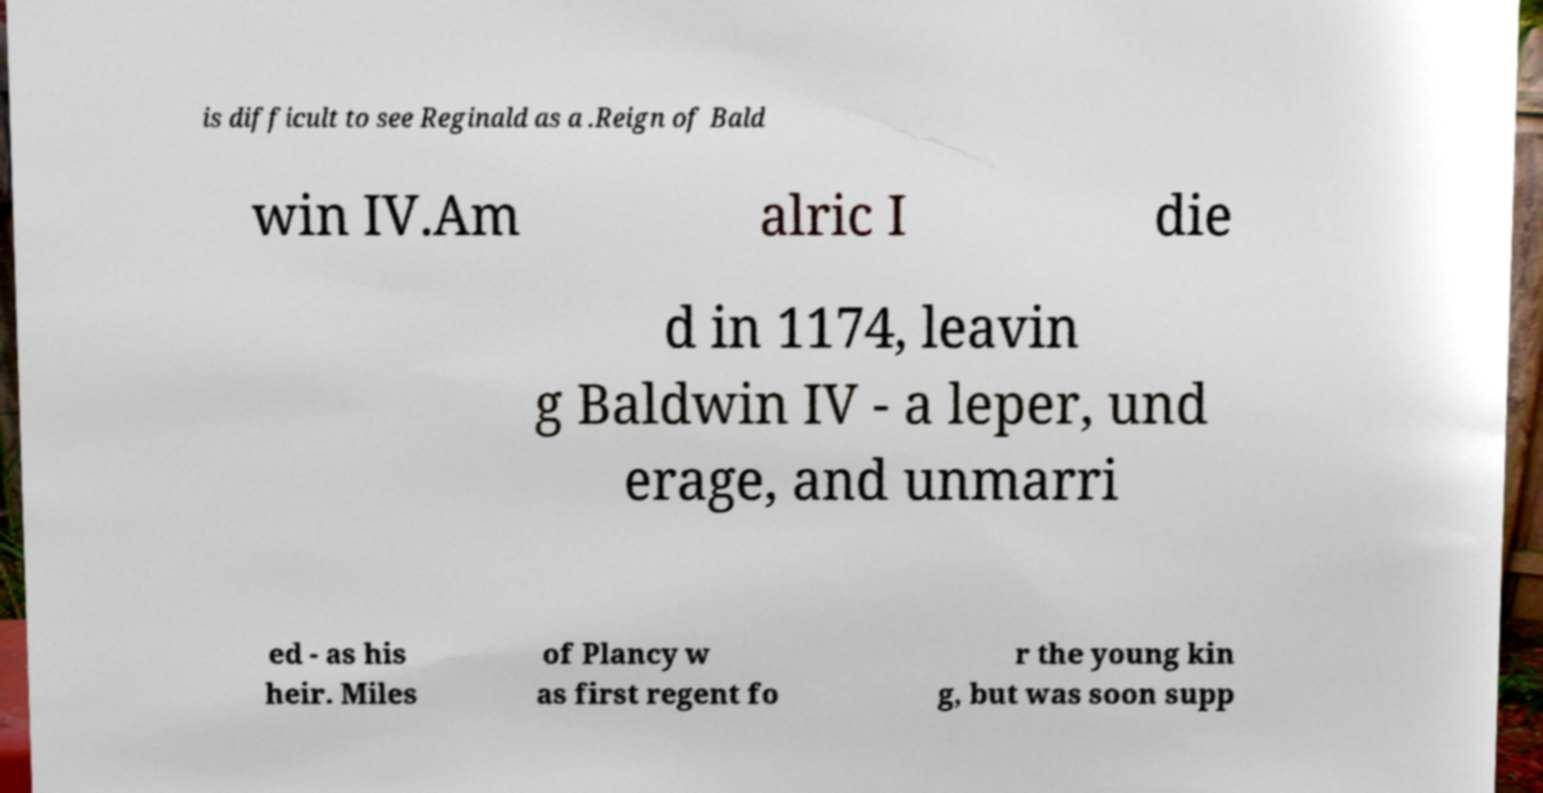Can you accurately transcribe the text from the provided image for me? is difficult to see Reginald as a .Reign of Bald win IV.Am alric I die d in 1174, leavin g Baldwin IV - a leper, und erage, and unmarri ed - as his heir. Miles of Plancy w as first regent fo r the young kin g, but was soon supp 